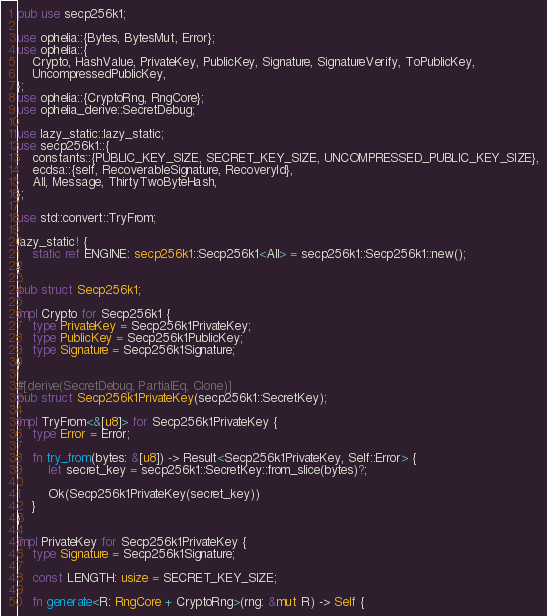<code> <loc_0><loc_0><loc_500><loc_500><_Rust_>pub use secp256k1;

use ophelia::{Bytes, BytesMut, Error};
use ophelia::{
    Crypto, HashValue, PrivateKey, PublicKey, Signature, SignatureVerify, ToPublicKey,
    UncompressedPublicKey,
};
use ophelia::{CryptoRng, RngCore};
use ophelia_derive::SecretDebug;

use lazy_static::lazy_static;
use secp256k1::{
    constants::{PUBLIC_KEY_SIZE, SECRET_KEY_SIZE, UNCOMPRESSED_PUBLIC_KEY_SIZE},
    ecdsa::{self, RecoverableSignature, RecoveryId},
    All, Message, ThirtyTwoByteHash,
};

use std::convert::TryFrom;

lazy_static! {
    static ref ENGINE: secp256k1::Secp256k1<All> = secp256k1::Secp256k1::new();
}

pub struct Secp256k1;

impl Crypto for Secp256k1 {
    type PrivateKey = Secp256k1PrivateKey;
    type PublicKey = Secp256k1PublicKey;
    type Signature = Secp256k1Signature;
}

#[derive(SecretDebug, PartialEq, Clone)]
pub struct Secp256k1PrivateKey(secp256k1::SecretKey);

impl TryFrom<&[u8]> for Secp256k1PrivateKey {
    type Error = Error;

    fn try_from(bytes: &[u8]) -> Result<Secp256k1PrivateKey, Self::Error> {
        let secret_key = secp256k1::SecretKey::from_slice(bytes)?;

        Ok(Secp256k1PrivateKey(secret_key))
    }
}

impl PrivateKey for Secp256k1PrivateKey {
    type Signature = Secp256k1Signature;

    const LENGTH: usize = SECRET_KEY_SIZE;

    fn generate<R: RngCore + CryptoRng>(rng: &mut R) -> Self {</code> 